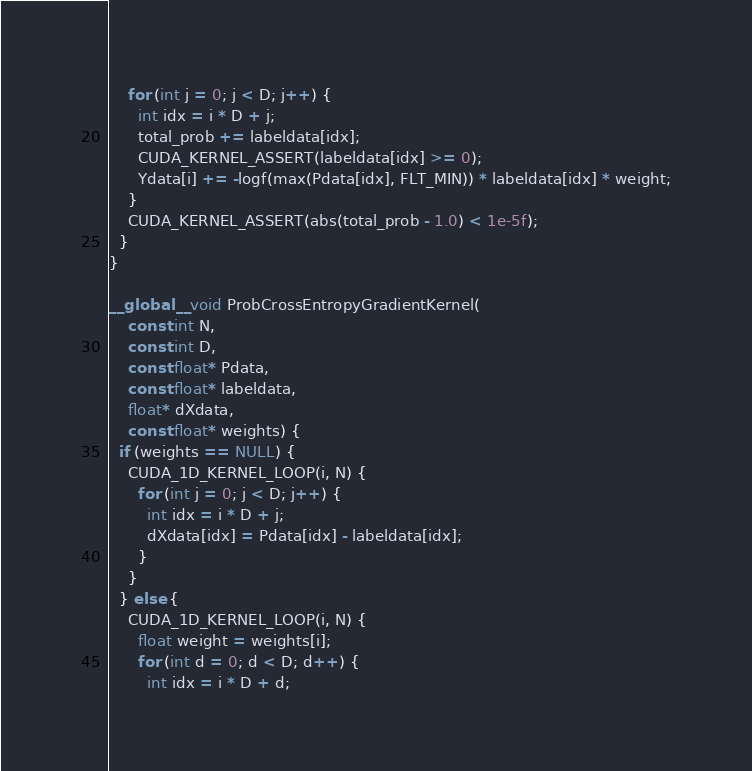Convert code to text. <code><loc_0><loc_0><loc_500><loc_500><_Cuda_>    for (int j = 0; j < D; j++) {
      int idx = i * D + j;
      total_prob += labeldata[idx];
      CUDA_KERNEL_ASSERT(labeldata[idx] >= 0);
      Ydata[i] += -logf(max(Pdata[idx], FLT_MIN)) * labeldata[idx] * weight;
    }
    CUDA_KERNEL_ASSERT(abs(total_prob - 1.0) < 1e-5f);
  }
}

__global__ void ProbCrossEntropyGradientKernel(
    const int N,
    const int D,
    const float* Pdata,
    const float* labeldata,
    float* dXdata,
    const float* weights) {
  if (weights == NULL) {
    CUDA_1D_KERNEL_LOOP(i, N) {
      for (int j = 0; j < D; j++) {
        int idx = i * D + j;
        dXdata[idx] = Pdata[idx] - labeldata[idx];
      }
    }
  } else {
    CUDA_1D_KERNEL_LOOP(i, N) {
      float weight = weights[i];
      for (int d = 0; d < D; d++) {
        int idx = i * D + d;</code> 